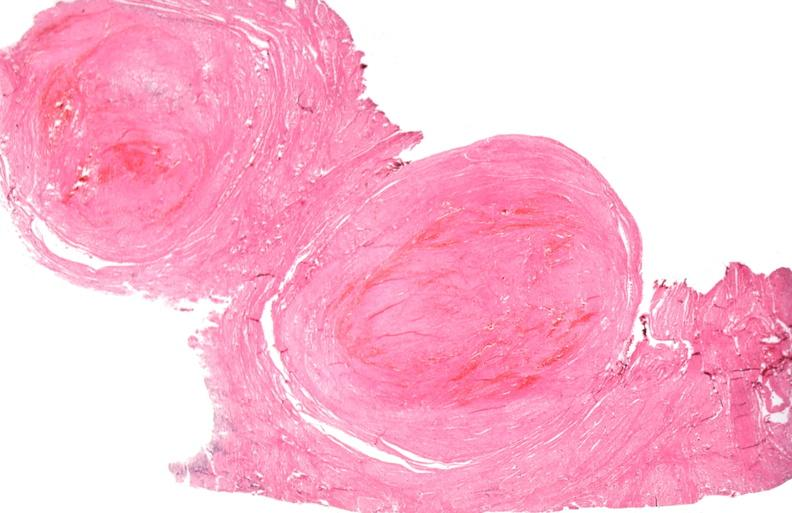does this image show uterus, leiomyoma?
Answer the question using a single word or phrase. Yes 